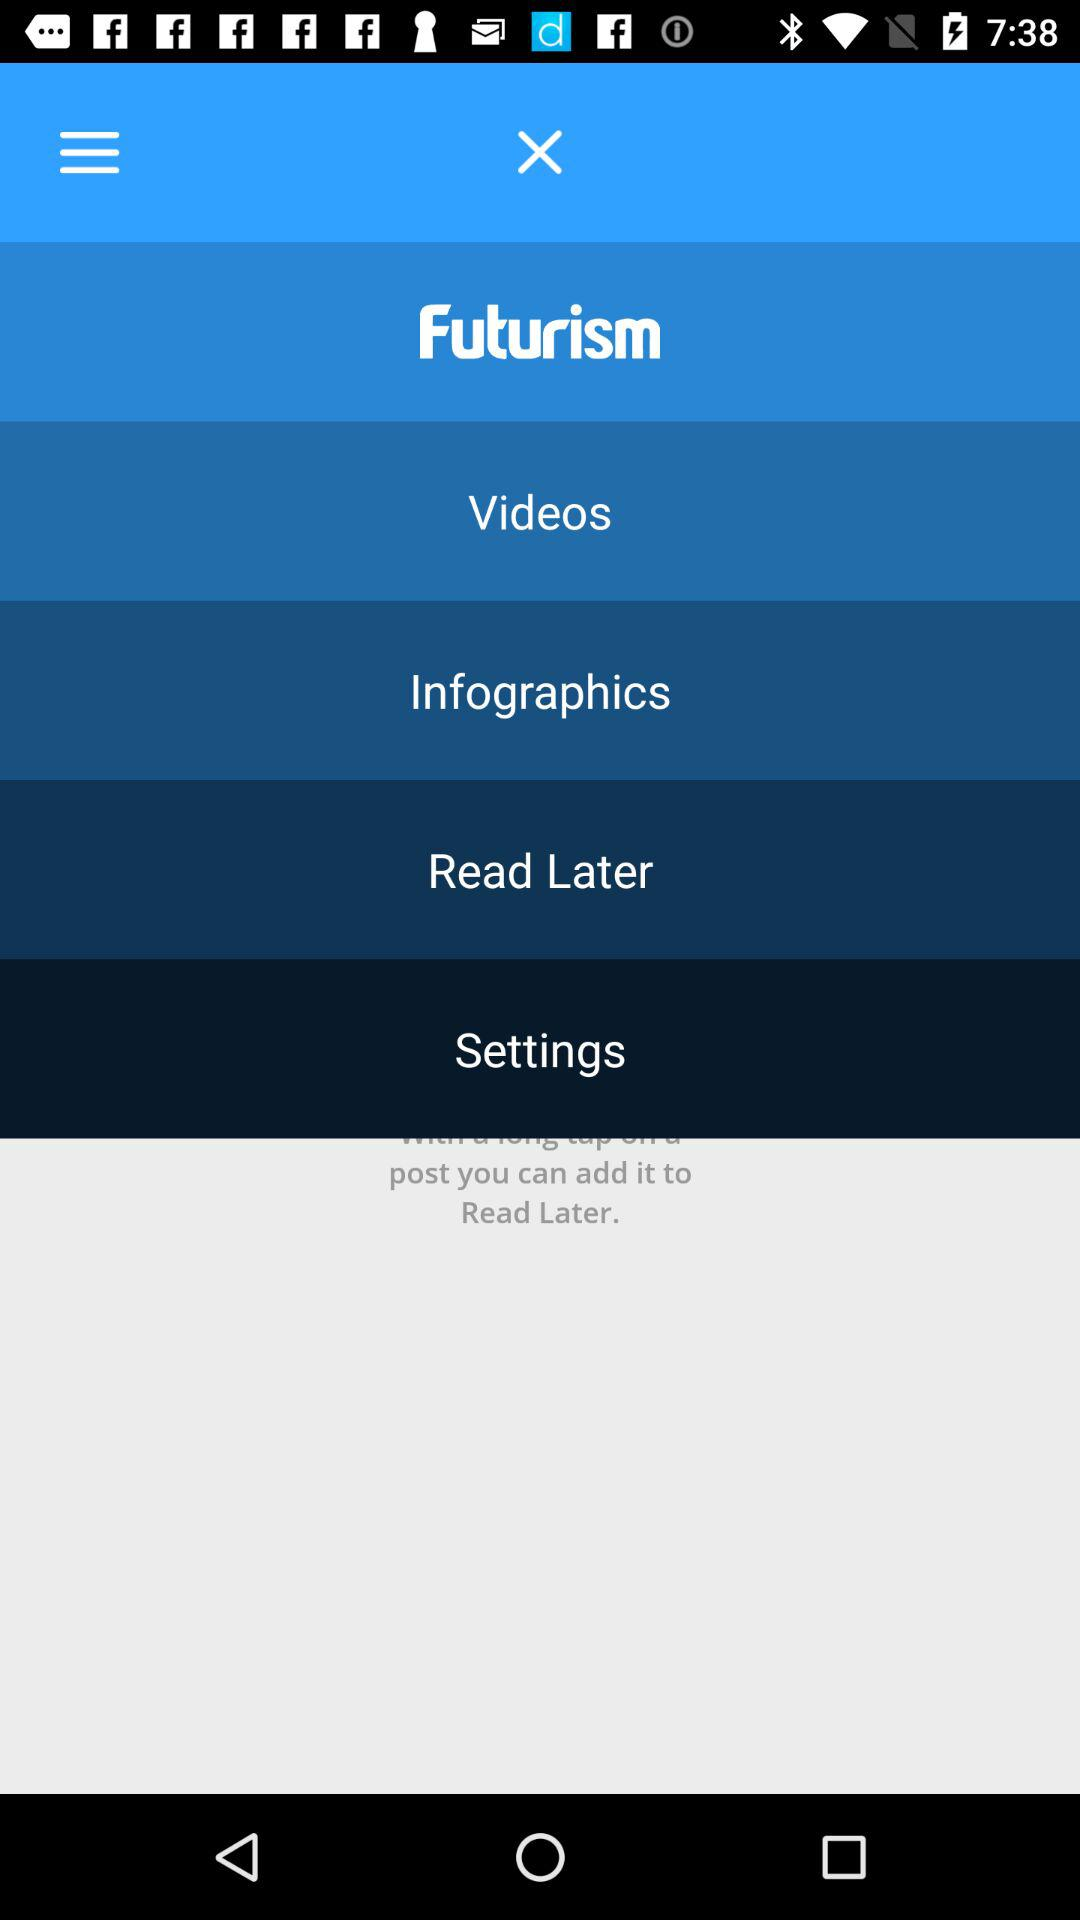Which option is selected? The selected option is "Futurism". 